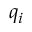Convert formula to latex. <formula><loc_0><loc_0><loc_500><loc_500>q _ { i }</formula> 